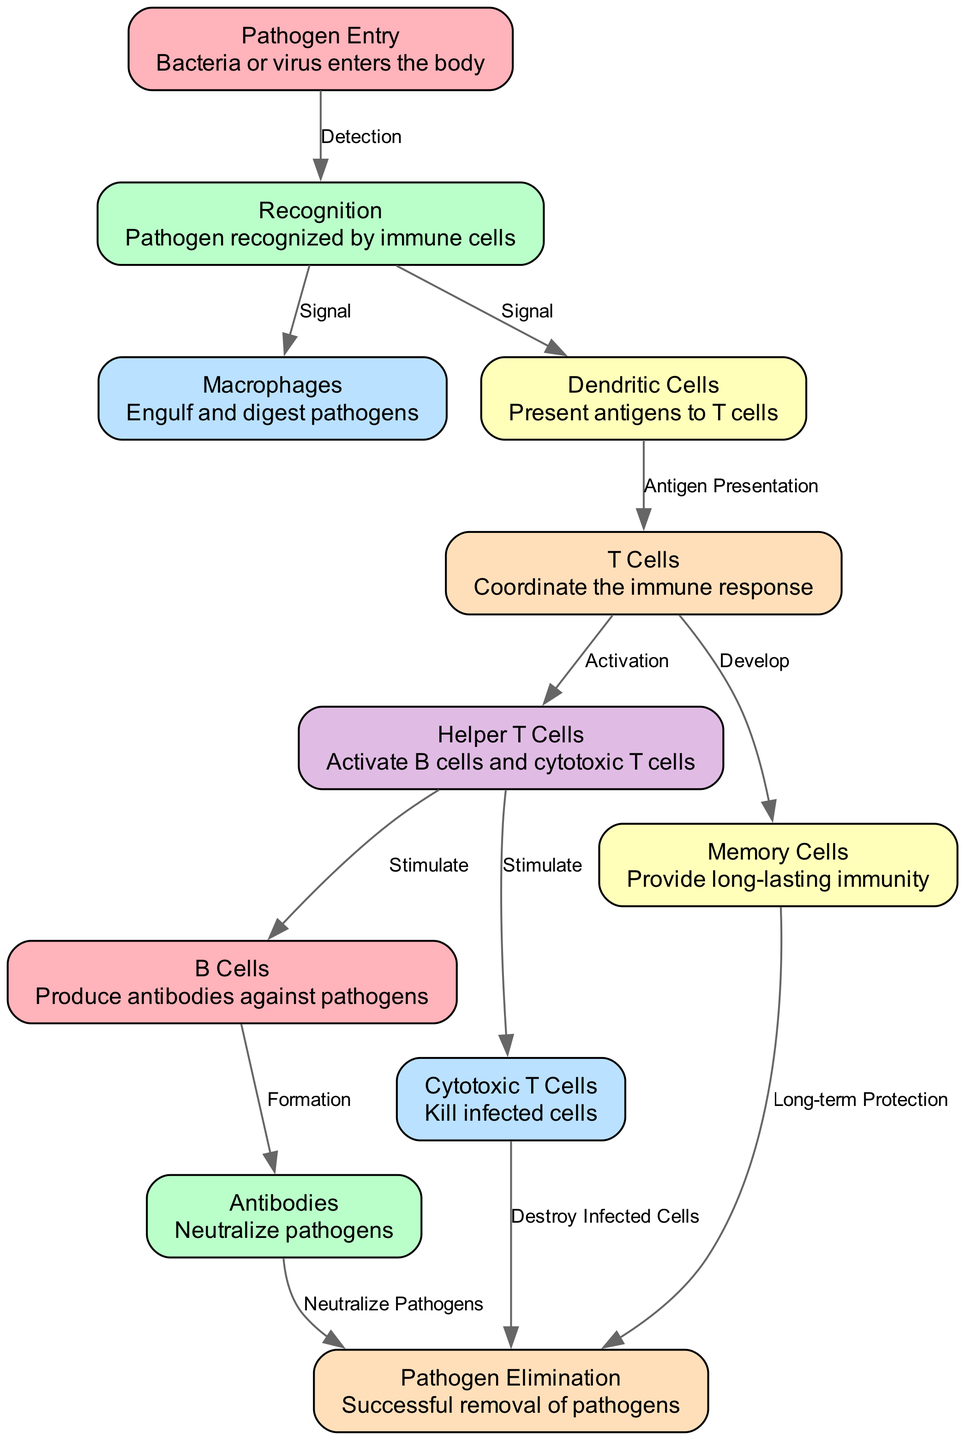What is the first step in the immune response? The diagram begins with the "Pathogen Entry" node, indicating that the first step occurs when a bacteria or virus enters the body.
Answer: Pathogen Entry How many total nodes are present in the diagram? By counting each unique step in the immune response depicted in the diagram, there are a total of 11 nodes.
Answer: 11 What happens after the pathogen is recognized by immune cells? The diagram shows that after "Recognition," the next steps involve signaling both "Macrophages" to engulf pathogens and "Dendritic Cells" to present antigens to T cells.
Answer: Signal Which immune cells engage in the production of antibodies? The "B Cells" node in the diagram specifically states that these cells are responsible for producing antibodies against pathogens.
Answer: B Cells What is the final outcome depicted in the diagram? The last node indicates "Pathogen Elimination," meaning that the successful removal of pathogens is the final result of the immune response process illustrated.
Answer: Pathogen Elimination How do helper T cells contribute to the immune response? The diagram indicates that "Helper T Cells" activate both B cells and cytotoxic T cells, coordinating the immune response.
Answer: Activate B cells and cytotoxic T cells What function do memory cells serve in the immune system? According to the diagram, "Memory Cells" develop to provide long-lasting immunity against future infections from the same pathogen.
Answer: Long-lasting immunity Which two types of cells are stimulated by helper T cells? The diagram shows that "Helper T Cells" stimulate both "B Cells" and "Cytotoxic T Cells" in the immune response.
Answer: B Cells and Cytotoxic T Cells What role do antibodies play in the immune response? The diagram states that "Antibodies" neutralize pathogens, which is a key function in defending against infections.
Answer: Neutralize pathogens 